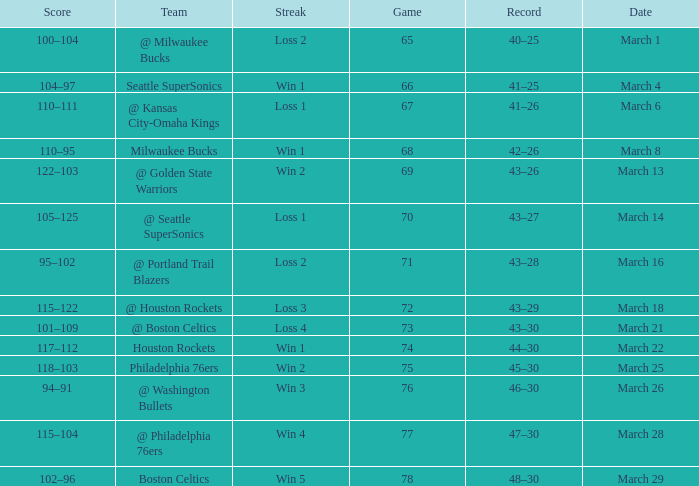What is the lowest Game, when Date is March 21? 73.0. 